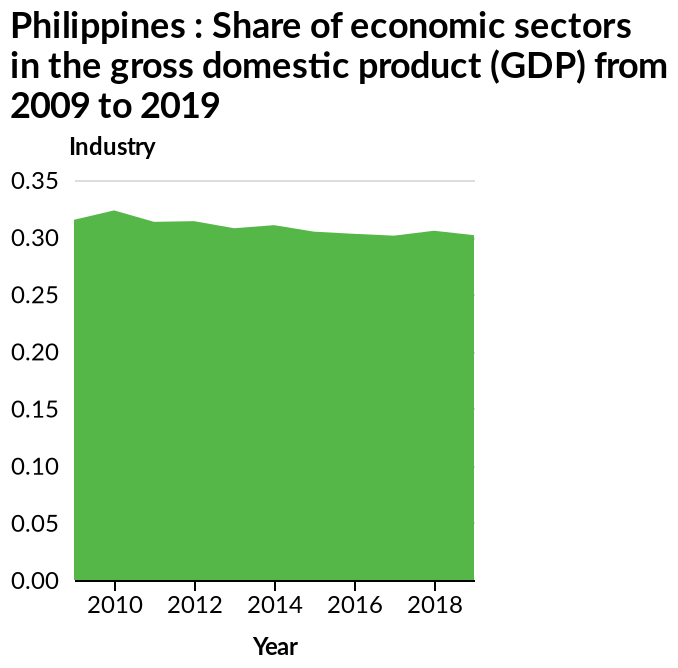<image>
please summary the statistics and relations of the chart Share of economic sectors in the gross domestic product peaked around 2010. Since 2010 there has been a slight, steady decline, until it appears to start flattening out around 2017. When did the decline in the share of economic sectors in the gross domestic product start stabilizing? The decline in the share of economic sectors in the gross domestic product appears to start flattening out around 2017. 